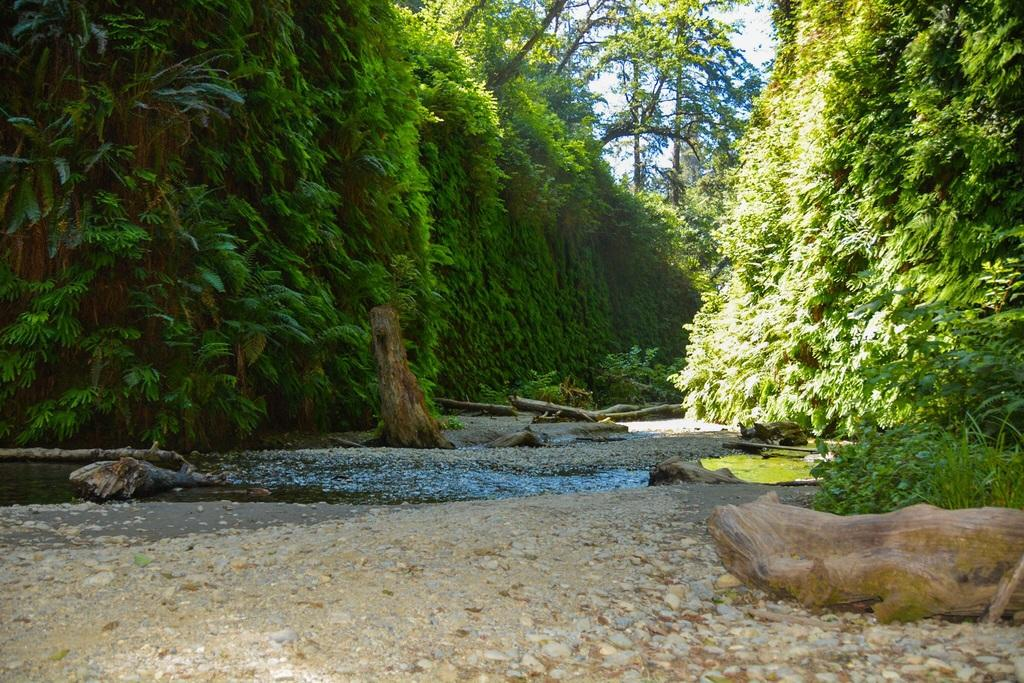What is located in the foreground of the image? There is a ground in the foreground of the image. What can be found on the ground in the image? There are trunks on the ground. What else is visible in the image besides the ground and trunks? There is water visible in the image, as well as trees and the sky. What type of calendar is hanging from the tree in the image? There is no calendar present in the image; it features a ground, trunks, water, trees, and the sky. 